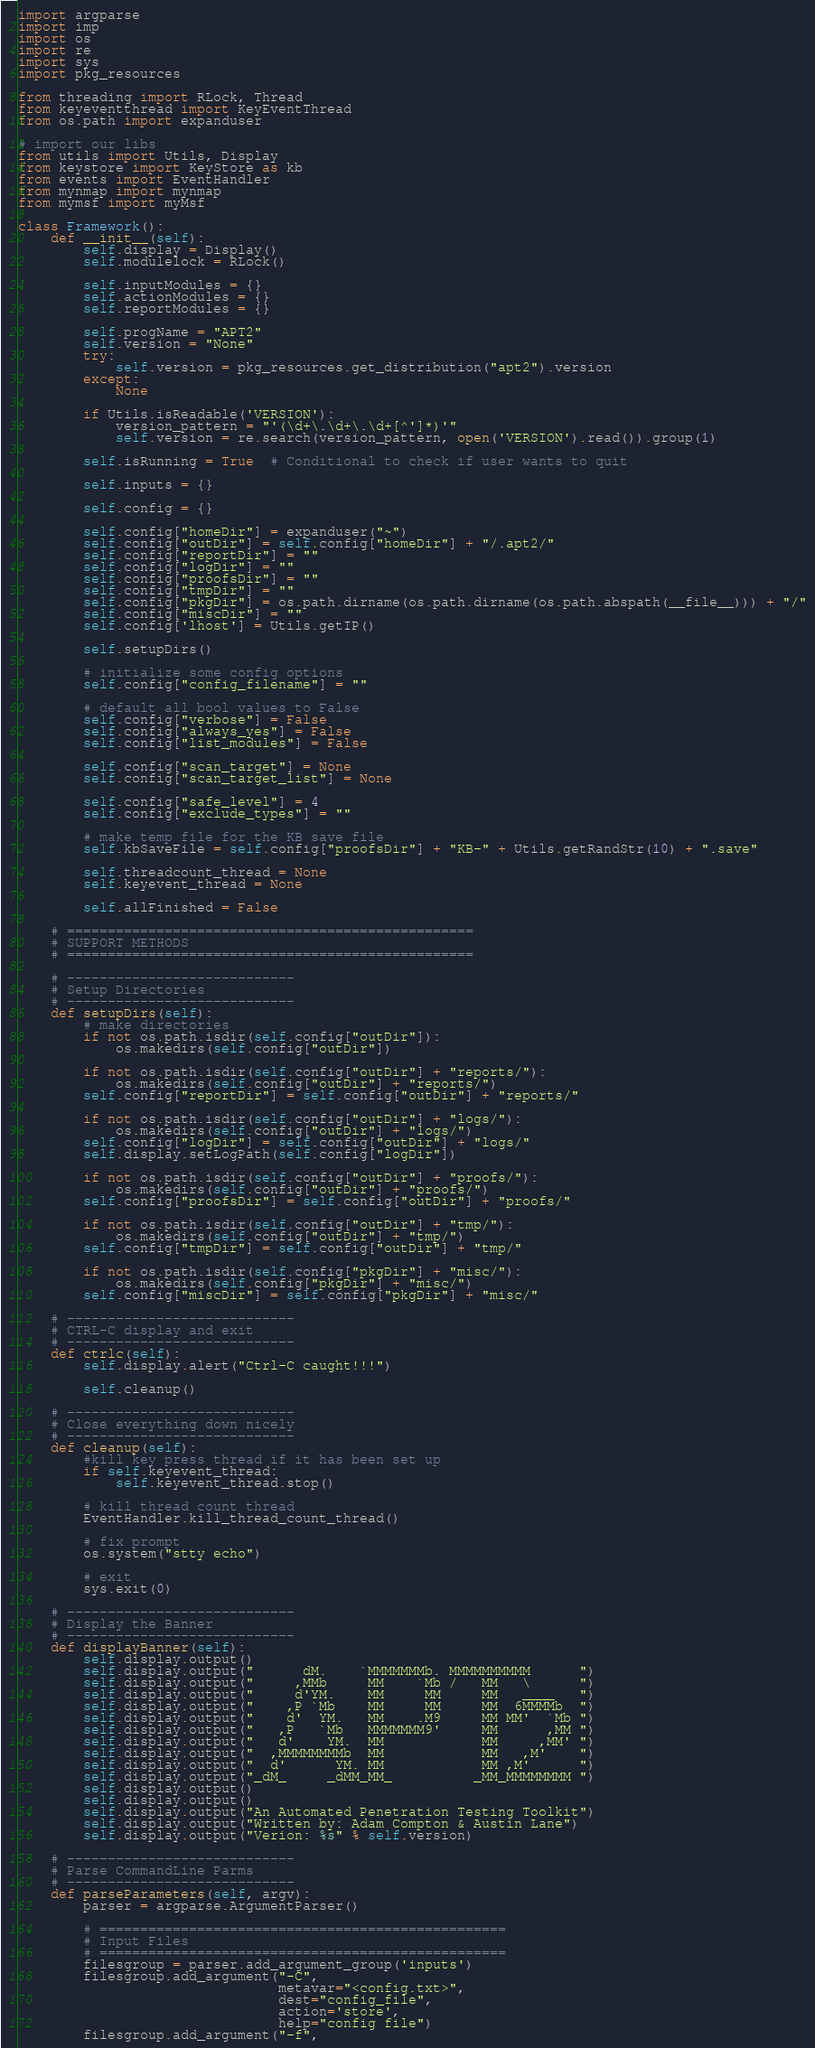<code> <loc_0><loc_0><loc_500><loc_500><_Python_>import argparse
import imp
import os
import re
import sys
import pkg_resources

from threading import RLock, Thread
from keyeventthread import KeyEventThread
from os.path import expanduser

# import our libs
from utils import Utils, Display
from keystore import KeyStore as kb
from events import EventHandler
from mynmap import mynmap
from mymsf import myMsf

class Framework():
    def __init__(self):
        self.display = Display()
        self.modulelock = RLock()

        self.inputModules = {}
        self.actionModules = {}
        self.reportModules = {}

        self.progName = "APT2"
        self.version = "None"
        try:
            self.version = pkg_resources.get_distribution("apt2").version
        except:
            None

        if Utils.isReadable('VERSION'):
            version_pattern = "'(\d+\.\d+\.\d+[^']*)'"
            self.version = re.search(version_pattern, open('VERSION').read()).group(1)

        self.isRunning = True  # Conditional to check if user wants to quit

        self.inputs = {}

        self.config = {}

        self.config["homeDir"] = expanduser("~")
        self.config["outDir"] = self.config["homeDir"] + "/.apt2/"
        self.config["reportDir"] = ""
        self.config["logDir"] = ""
        self.config["proofsDir"] = ""
        self.config["tmpDir"] = ""
        self.config["pkgDir"] = os.path.dirname(os.path.dirname(os.path.abspath(__file__))) + "/"
        self.config["miscDir"] = ""
        self.config['lhost'] = Utils.getIP()

        self.setupDirs()

        # initialize some config options
        self.config["config_filename"] = ""

        # default all bool values to False
        self.config["verbose"] = False
        self.config["always_yes"] = False
        self.config["list_modules"] = False

        self.config["scan_target"] = None
        self.config["scan_target_list"] = None

        self.config["safe_level"] = 4
        self.config["exclude_types"] = ""

        # make temp file for the KB save file
        self.kbSaveFile = self.config["proofsDir"] + "KB-" + Utils.getRandStr(10) + ".save"

        self.threadcount_thread = None
        self.keyevent_thread = None

        self.allFinished = False

    # ==================================================
    # SUPPORT METHODS
    # ==================================================

    # ----------------------------
    # Setup Directories
    # ----------------------------
    def setupDirs(self):
        # make directories
        if not os.path.isdir(self.config["outDir"]):
            os.makedirs(self.config["outDir"])

        if not os.path.isdir(self.config["outDir"] + "reports/"):
            os.makedirs(self.config["outDir"] + "reports/")
        self.config["reportDir"] = self.config["outDir"] + "reports/"

        if not os.path.isdir(self.config["outDir"] + "logs/"):
            os.makedirs(self.config["outDir"] + "logs/")
        self.config["logDir"] = self.config["outDir"] + "logs/"
        self.display.setLogPath(self.config["logDir"])

        if not os.path.isdir(self.config["outDir"] + "proofs/"):
            os.makedirs(self.config["outDir"] + "proofs/")
        self.config["proofsDir"] = self.config["outDir"] + "proofs/"

        if not os.path.isdir(self.config["outDir"] + "tmp/"):
            os.makedirs(self.config["outDir"] + "tmp/")
        self.config["tmpDir"] = self.config["outDir"] + "tmp/"

        if not os.path.isdir(self.config["pkgDir"] + "misc/"):
            os.makedirs(self.config["pkgDir"] + "misc/")
        self.config["miscDir"] = self.config["pkgDir"] + "misc/"

    # ----------------------------
    # CTRL-C display and exit
    # ----------------------------
    def ctrlc(self):
        self.display.alert("Ctrl-C caught!!!")

        self.cleanup()

    # ----------------------------
    # Close everything down nicely
    # ----------------------------
    def cleanup(self):
        #kill key press thread if it has been set up
        if self.keyevent_thread:
            self.keyevent_thread.stop()

        # kill thread count thread
        EventHandler.kill_thread_count_thread()

        # fix prompt
        os.system("stty echo")

        # exit
        sys.exit(0)

    # ----------------------------
    # Display the Banner
    # ----------------------------
    def displayBanner(self):
        self.display.output()
        self.display.output("      dM.    `MMMMMMMb. MMMMMMMMMM      ")
        self.display.output("     ,MMb     MM    `Mb /   MM   \      ")
        self.display.output("     d'YM.    MM     MM     MM   ____   ")
        self.display.output("    ,P `Mb    MM     MM     MM  6MMMMb  ")
        self.display.output("    d'  YM.   MM    .M9     MM MM'  `Mb ")
        self.display.output("   ,P   `Mb   MMMMMMM9'     MM      ,MM ")
        self.display.output("   d'    YM.  MM            MM     ,MM' ")
        self.display.output("  ,MMMMMMMMb  MM            MM   ,M'    ")
        self.display.output("  d'      YM. MM            MM ,M'      ")
        self.display.output("_dM_     _dMM_MM_          _MM_MMMMMMMM ")
        self.display.output()
        self.display.output()
        self.display.output("An Automated Penetration Testing Toolkit")
        self.display.output("Written by: Adam Compton & Austin Lane")
        self.display.output("Verion: %s" % self.version)

    # ----------------------------
    # Parse CommandLine Parms
    # ----------------------------
    def parseParameters(self, argv):
        parser = argparse.ArgumentParser()

        # ==================================================
        # Input Files
        # ==================================================
        filesgroup = parser.add_argument_group('inputs')
        filesgroup.add_argument("-C",
                                metavar="<config.txt>",
                                dest="config_file",
                                action='store',
                                help="config file")
        filesgroup.add_argument("-f",</code> 